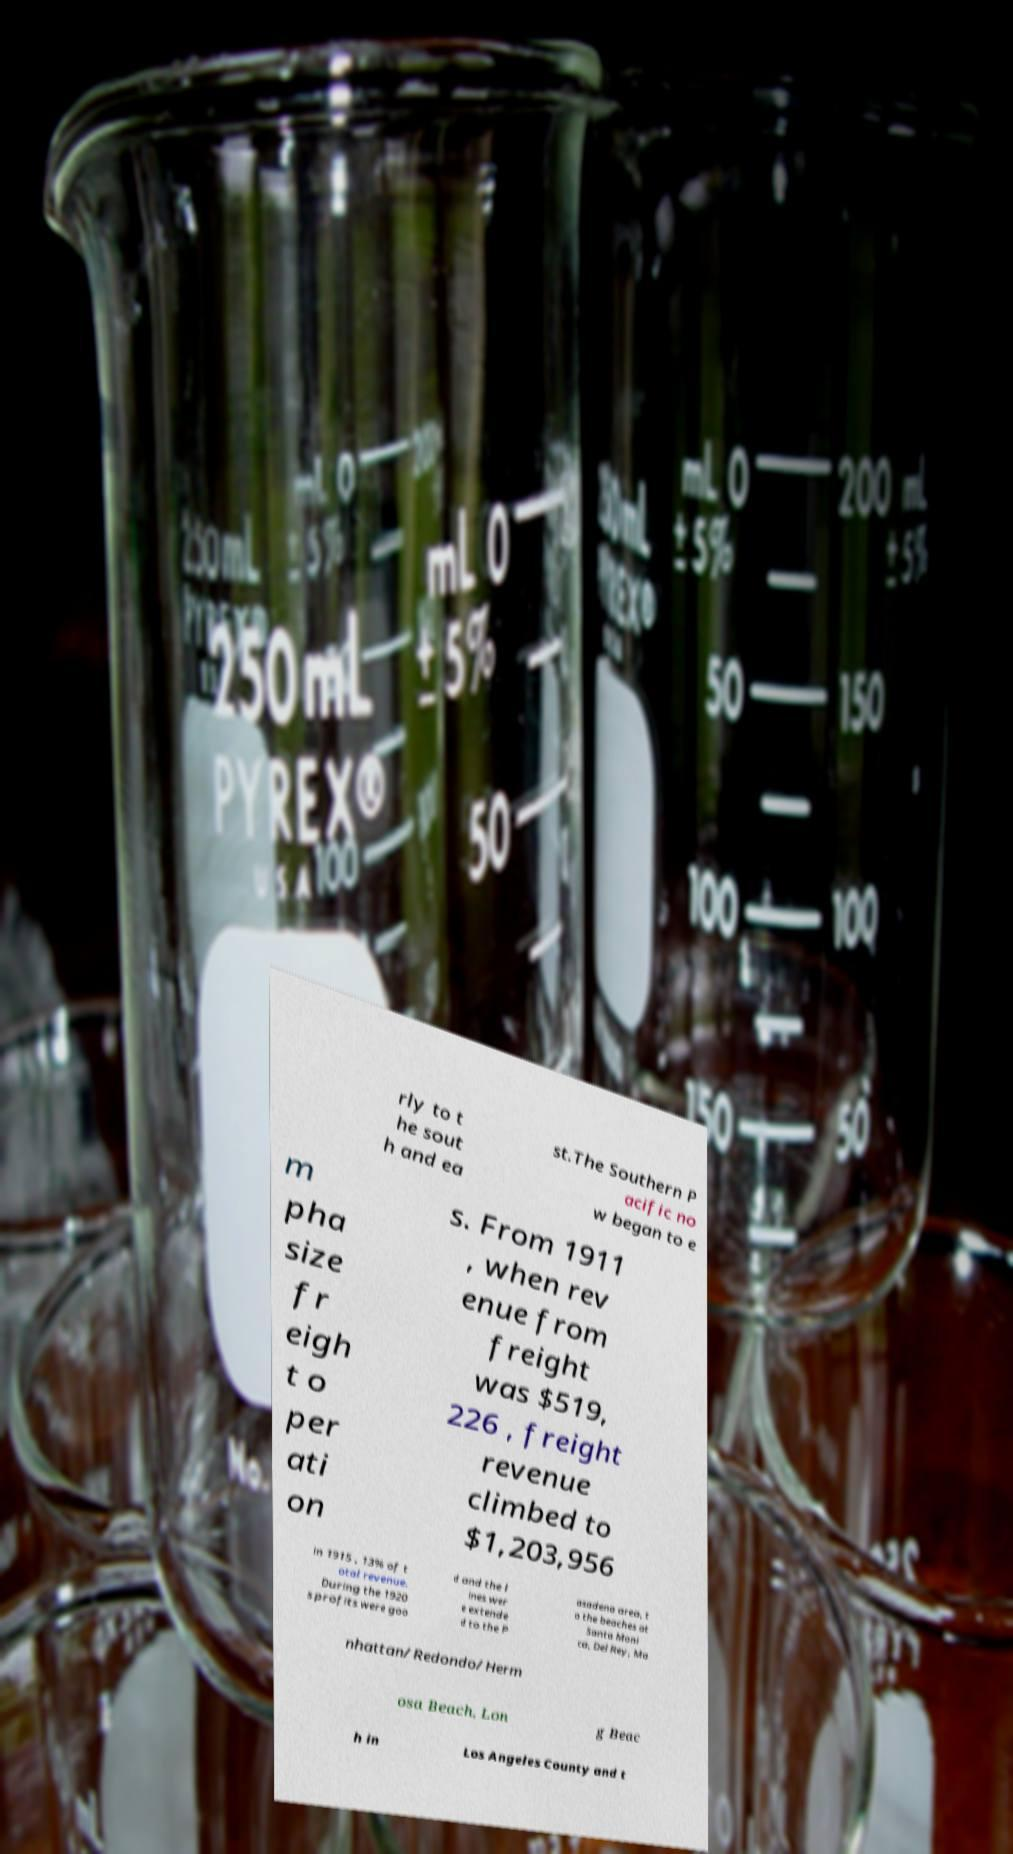Can you read and provide the text displayed in the image?This photo seems to have some interesting text. Can you extract and type it out for me? rly to t he sout h and ea st.The Southern P acific no w began to e m pha size fr eigh t o per ati on s. From 1911 , when rev enue from freight was $519, 226 , freight revenue climbed to $1,203,956 in 1915 , 13% of t otal revenue. During the 1920 s profits were goo d and the l ines wer e extende d to the P asadena area, t o the beaches at Santa Moni ca, Del Rey, Ma nhattan/Redondo/Herm osa Beach, Lon g Beac h in Los Angeles County and t 